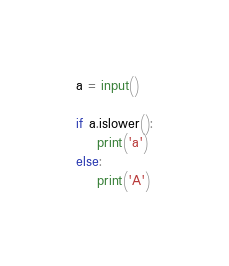Convert code to text. <code><loc_0><loc_0><loc_500><loc_500><_Python_>a = input()

if a.islower():
    print('a')
else:
    print('A')
</code> 